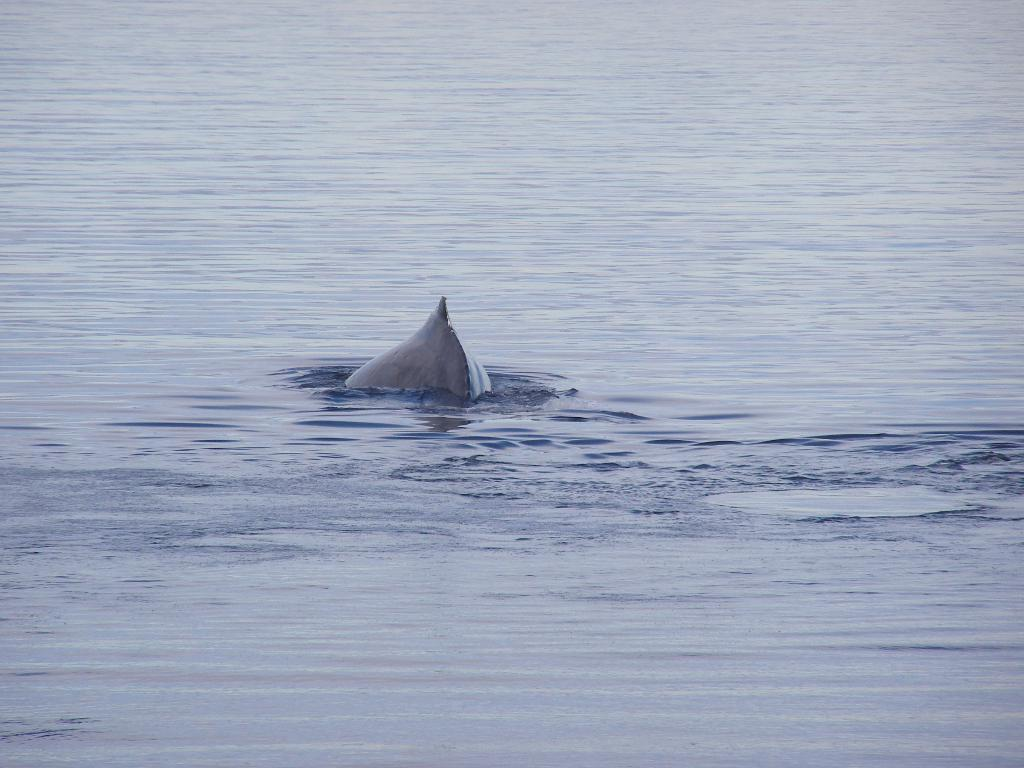What type of animal is in the image? There is a fish in the image. Where is the fish located? The fish is in the water. What type of trucks can be seen carrying quince in the image? There are no trucks or quince present in the image; it features a fish in the water. What color is the beetle that is crawling on the fish in the image? There is no beetle present in the image; it only features a fish in the water. 